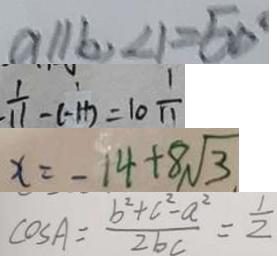<formula> <loc_0><loc_0><loc_500><loc_500>a / / b , \angle 1 = 5 0 ^ { \circ } 
 \frac { 1 } { 1 1 } - ( - 1 1 ) = 1 0 \frac { 1 } { 1 1 } 
 x = - 1 4 + 8 \sqrt { 3 } 
 \cos A = \frac { b ^ { 2 } + c ^ { 2 } - a ^ { 2 } } { 2 b c } = \frac { 1 } { 2 }</formula> 